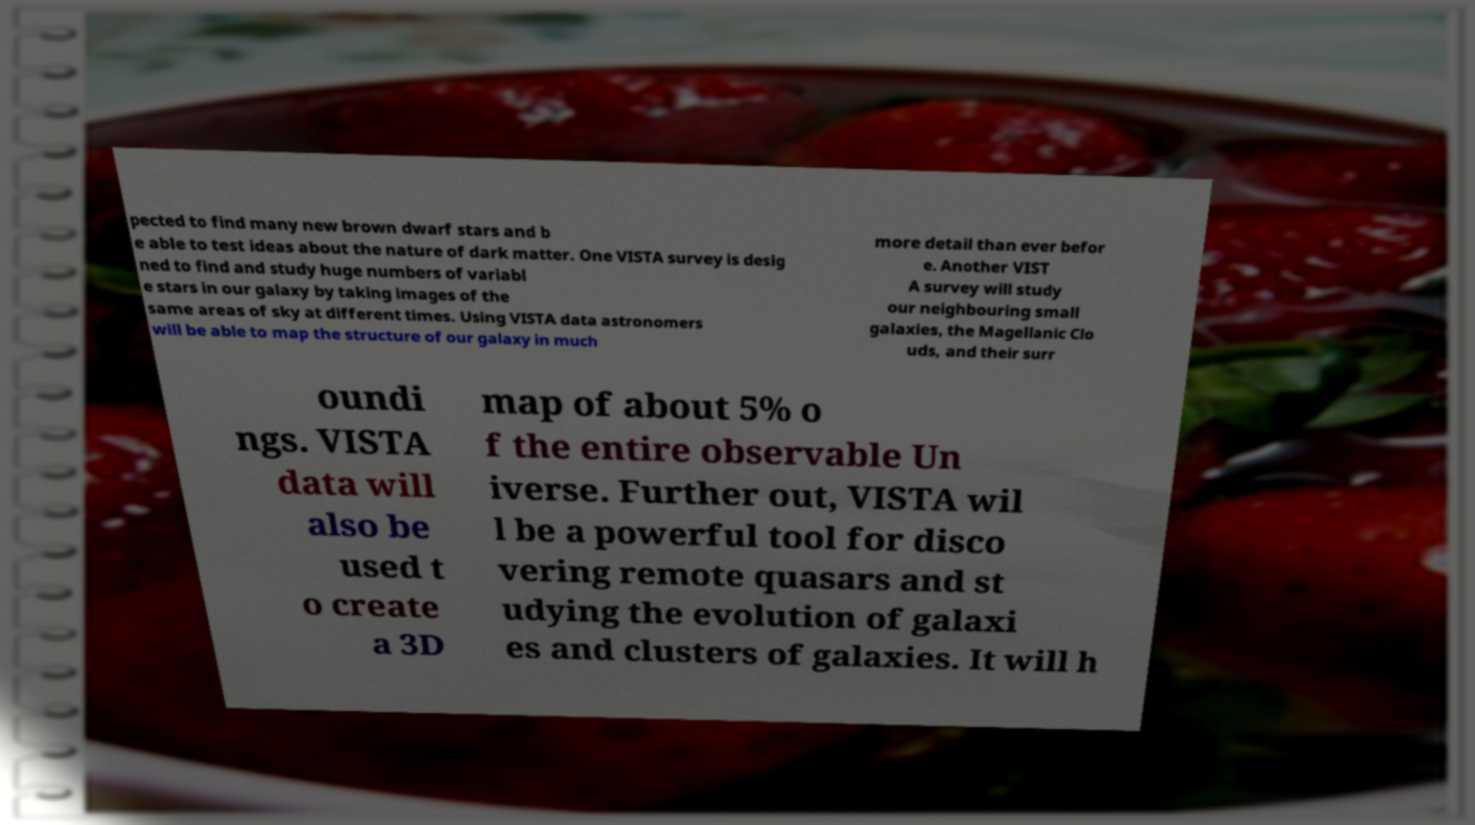Could you extract and type out the text from this image? pected to find many new brown dwarf stars and b e able to test ideas about the nature of dark matter. One VISTA survey is desig ned to find and study huge numbers of variabl e stars in our galaxy by taking images of the same areas of sky at different times. Using VISTA data astronomers will be able to map the structure of our galaxy in much more detail than ever befor e. Another VIST A survey will study our neighbouring small galaxies, the Magellanic Clo uds, and their surr oundi ngs. VISTA data will also be used t o create a 3D map of about 5% o f the entire observable Un iverse. Further out, VISTA wil l be a powerful tool for disco vering remote quasars and st udying the evolution of galaxi es and clusters of galaxies. It will h 